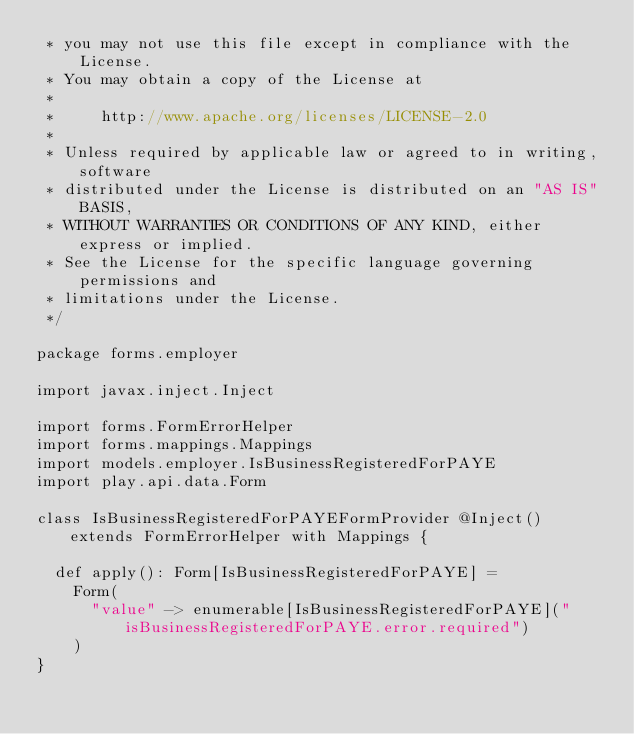<code> <loc_0><loc_0><loc_500><loc_500><_Scala_> * you may not use this file except in compliance with the License.
 * You may obtain a copy of the License at
 *
 *     http://www.apache.org/licenses/LICENSE-2.0
 *
 * Unless required by applicable law or agreed to in writing, software
 * distributed under the License is distributed on an "AS IS" BASIS,
 * WITHOUT WARRANTIES OR CONDITIONS OF ANY KIND, either express or implied.
 * See the License for the specific language governing permissions and
 * limitations under the License.
 */

package forms.employer

import javax.inject.Inject

import forms.FormErrorHelper
import forms.mappings.Mappings
import models.employer.IsBusinessRegisteredForPAYE
import play.api.data.Form

class IsBusinessRegisteredForPAYEFormProvider @Inject() extends FormErrorHelper with Mappings {

  def apply(): Form[IsBusinessRegisteredForPAYE] =
    Form(
      "value" -> enumerable[IsBusinessRegisteredForPAYE]("isBusinessRegisteredForPAYE.error.required")
    )
}
</code> 